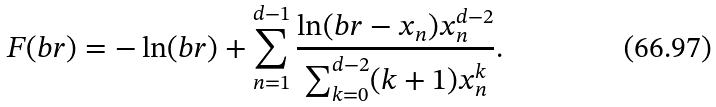Convert formula to latex. <formula><loc_0><loc_0><loc_500><loc_500>F ( b r ) = - \ln ( b r ) + \sum _ { n = 1 } ^ { d - 1 } \frac { \ln ( b r - x _ { n } ) x _ { n } ^ { d - 2 } } { \sum _ { k = 0 } ^ { d - 2 } ( k + 1 ) x _ { n } ^ { k } } .</formula> 